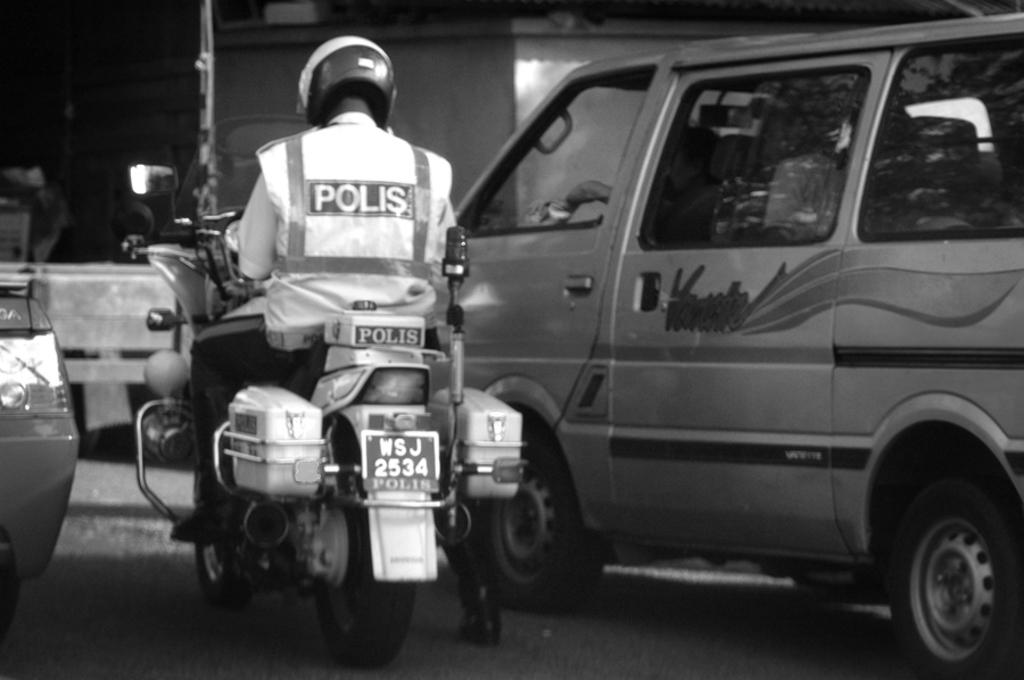What is the person in the image doing? The person is sitting on a bike in the image. What safety gear is the person wearing? The person is wearing a helmet in the image. What type of clothing is the person wearing? The person is wearing a jacket in the image. What can be seen on the road in the image? There are vehicles on the road in the image. What is visible in the background of the image? There is a wall and a pole visible in the background of the image. What type of insect can be seen crawling on the pen in the image? There is no insect or pen present in the image. 